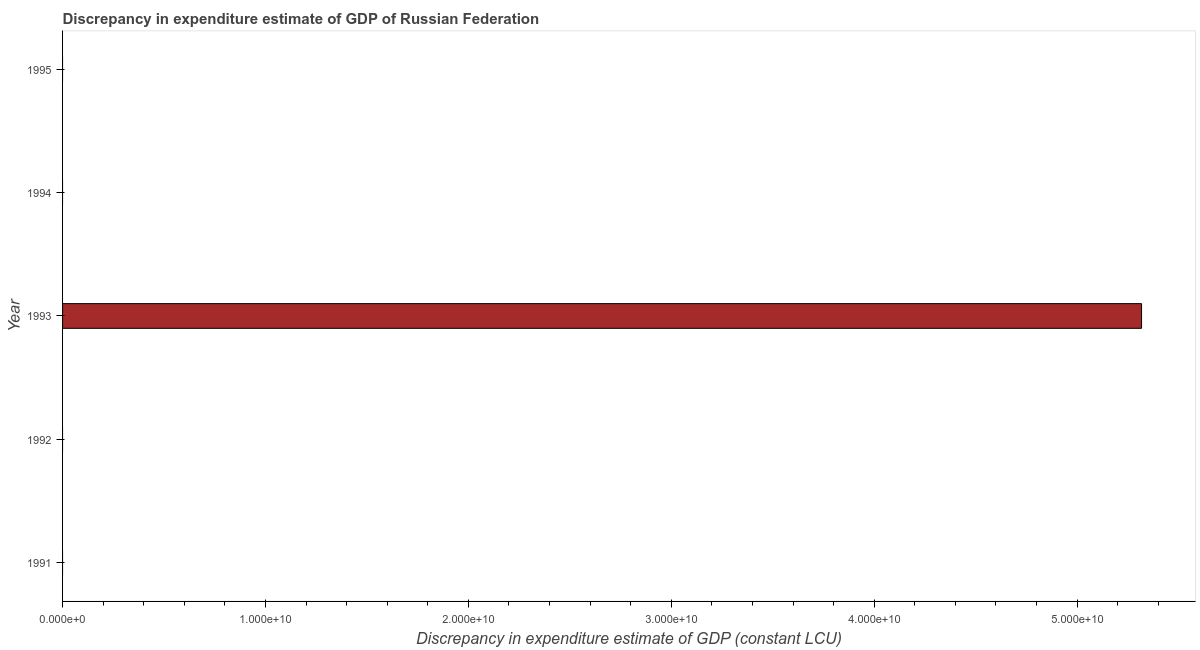Does the graph contain grids?
Keep it short and to the point. No. What is the title of the graph?
Provide a succinct answer. Discrepancy in expenditure estimate of GDP of Russian Federation. What is the label or title of the X-axis?
Your answer should be compact. Discrepancy in expenditure estimate of GDP (constant LCU). What is the label or title of the Y-axis?
Give a very brief answer. Year. Across all years, what is the maximum discrepancy in expenditure estimate of gdp?
Provide a succinct answer. 5.32e+1. Across all years, what is the minimum discrepancy in expenditure estimate of gdp?
Make the answer very short. 0. What is the sum of the discrepancy in expenditure estimate of gdp?
Make the answer very short. 5.32e+1. What is the average discrepancy in expenditure estimate of gdp per year?
Make the answer very short. 1.06e+1. In how many years, is the discrepancy in expenditure estimate of gdp greater than 6000000000 LCU?
Offer a terse response. 1. What is the difference between the highest and the lowest discrepancy in expenditure estimate of gdp?
Make the answer very short. 5.32e+1. In how many years, is the discrepancy in expenditure estimate of gdp greater than the average discrepancy in expenditure estimate of gdp taken over all years?
Offer a terse response. 1. How many bars are there?
Make the answer very short. 1. Are all the bars in the graph horizontal?
Make the answer very short. Yes. What is the difference between two consecutive major ticks on the X-axis?
Offer a very short reply. 1.00e+1. Are the values on the major ticks of X-axis written in scientific E-notation?
Provide a succinct answer. Yes. What is the Discrepancy in expenditure estimate of GDP (constant LCU) of 1991?
Your answer should be compact. 0. What is the Discrepancy in expenditure estimate of GDP (constant LCU) in 1992?
Your answer should be very brief. 0. What is the Discrepancy in expenditure estimate of GDP (constant LCU) in 1993?
Provide a succinct answer. 5.32e+1. What is the Discrepancy in expenditure estimate of GDP (constant LCU) of 1994?
Provide a short and direct response. 0. What is the Discrepancy in expenditure estimate of GDP (constant LCU) in 1995?
Keep it short and to the point. 0. 